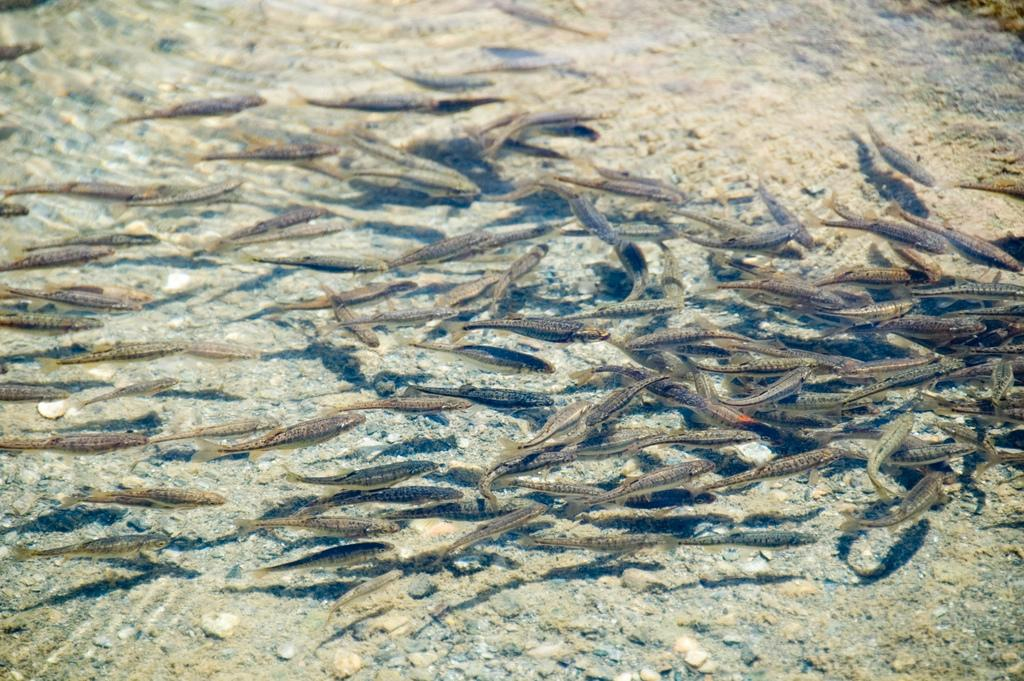What type of animals can be seen in the image? There are fishes in the image. In what environment are the fishes located? The fishes are in water. What type of addition can be seen in the image? There is no addition present in the image; it features fishes in water. What sign is visible in the image? There is no sign visible in the image; it features fishes in water. 